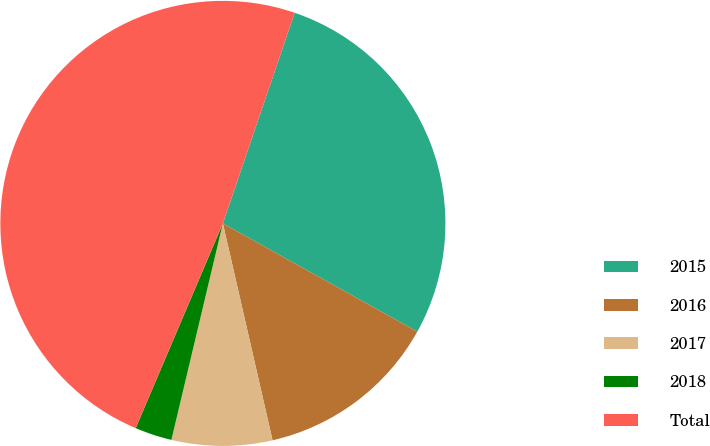<chart> <loc_0><loc_0><loc_500><loc_500><pie_chart><fcel>2015<fcel>2016<fcel>2017<fcel>2018<fcel>Total<nl><fcel>27.85%<fcel>13.33%<fcel>7.3%<fcel>2.69%<fcel>48.82%<nl></chart> 